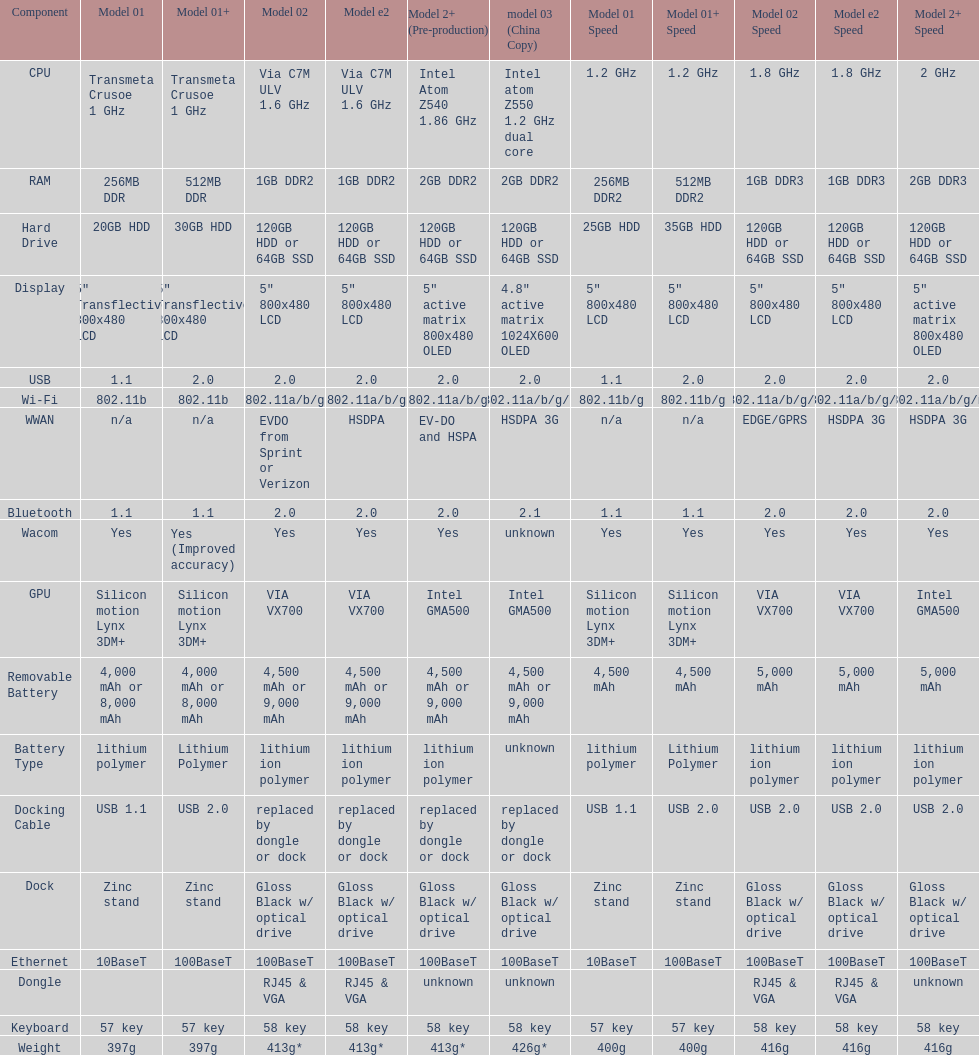What is the total number of components on the chart? 18. 